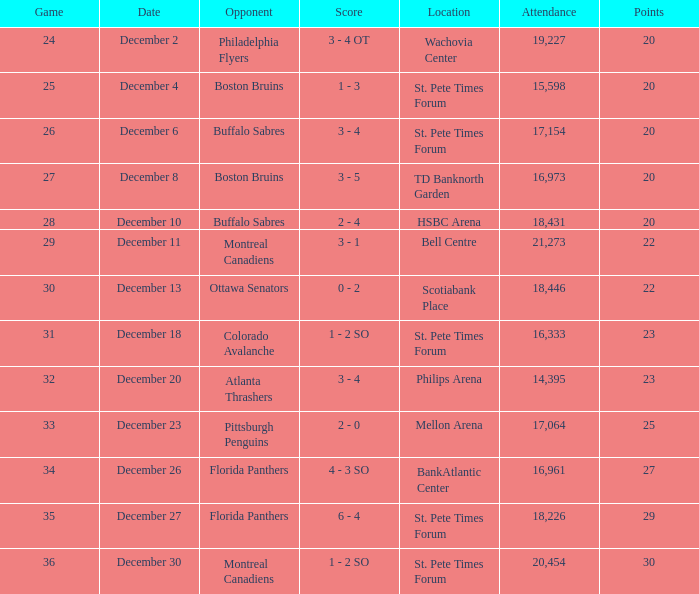What game has a 6-12-8 record? 26.0. 